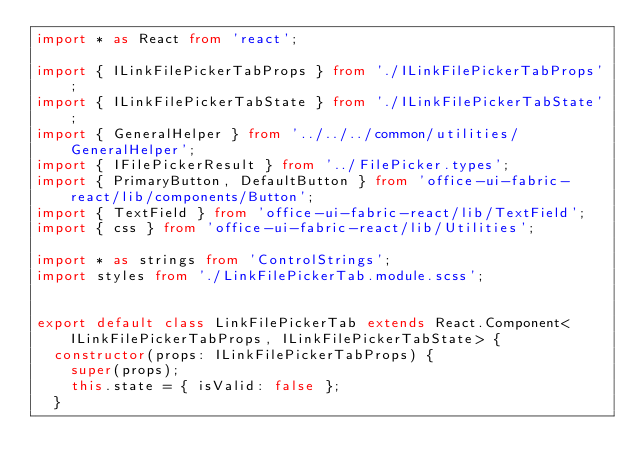Convert code to text. <code><loc_0><loc_0><loc_500><loc_500><_TypeScript_>import * as React from 'react';

import { ILinkFilePickerTabProps } from './ILinkFilePickerTabProps';
import { ILinkFilePickerTabState } from './ILinkFilePickerTabState';
import { GeneralHelper } from '../../../common/utilities/GeneralHelper';
import { IFilePickerResult } from '../FilePicker.types';
import { PrimaryButton, DefaultButton } from 'office-ui-fabric-react/lib/components/Button';
import { TextField } from 'office-ui-fabric-react/lib/TextField';
import { css } from 'office-ui-fabric-react/lib/Utilities';

import * as strings from 'ControlStrings';
import styles from './LinkFilePickerTab.module.scss';


export default class LinkFilePickerTab extends React.Component<ILinkFilePickerTabProps, ILinkFilePickerTabState> {
  constructor(props: ILinkFilePickerTabProps) {
    super(props);
    this.state = { isValid: false };
  }
</code> 